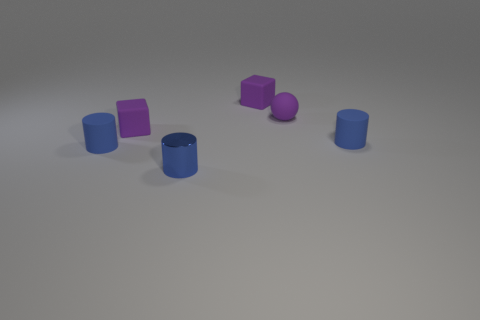Subtract all blue cylinders. How many were subtracted if there are1blue cylinders left? 2 Subtract all small blue metal cylinders. How many cylinders are left? 2 Add 4 large red rubber objects. How many objects exist? 10 Subtract all spheres. How many objects are left? 5 Subtract 1 blocks. How many blocks are left? 1 Subtract 0 red cylinders. How many objects are left? 6 Subtract all cyan blocks. Subtract all green cylinders. How many blocks are left? 2 Subtract all purple objects. Subtract all tiny purple things. How many objects are left? 0 Add 2 small cylinders. How many small cylinders are left? 5 Add 1 blue cylinders. How many blue cylinders exist? 4 